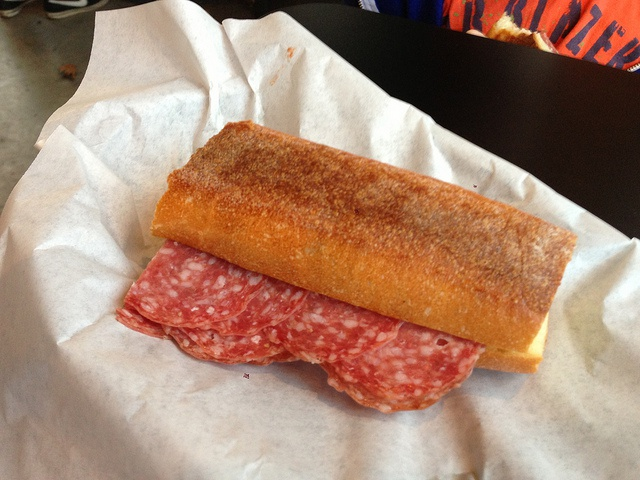Describe the objects in this image and their specific colors. I can see a sandwich in black, brown, and red tones in this image. 